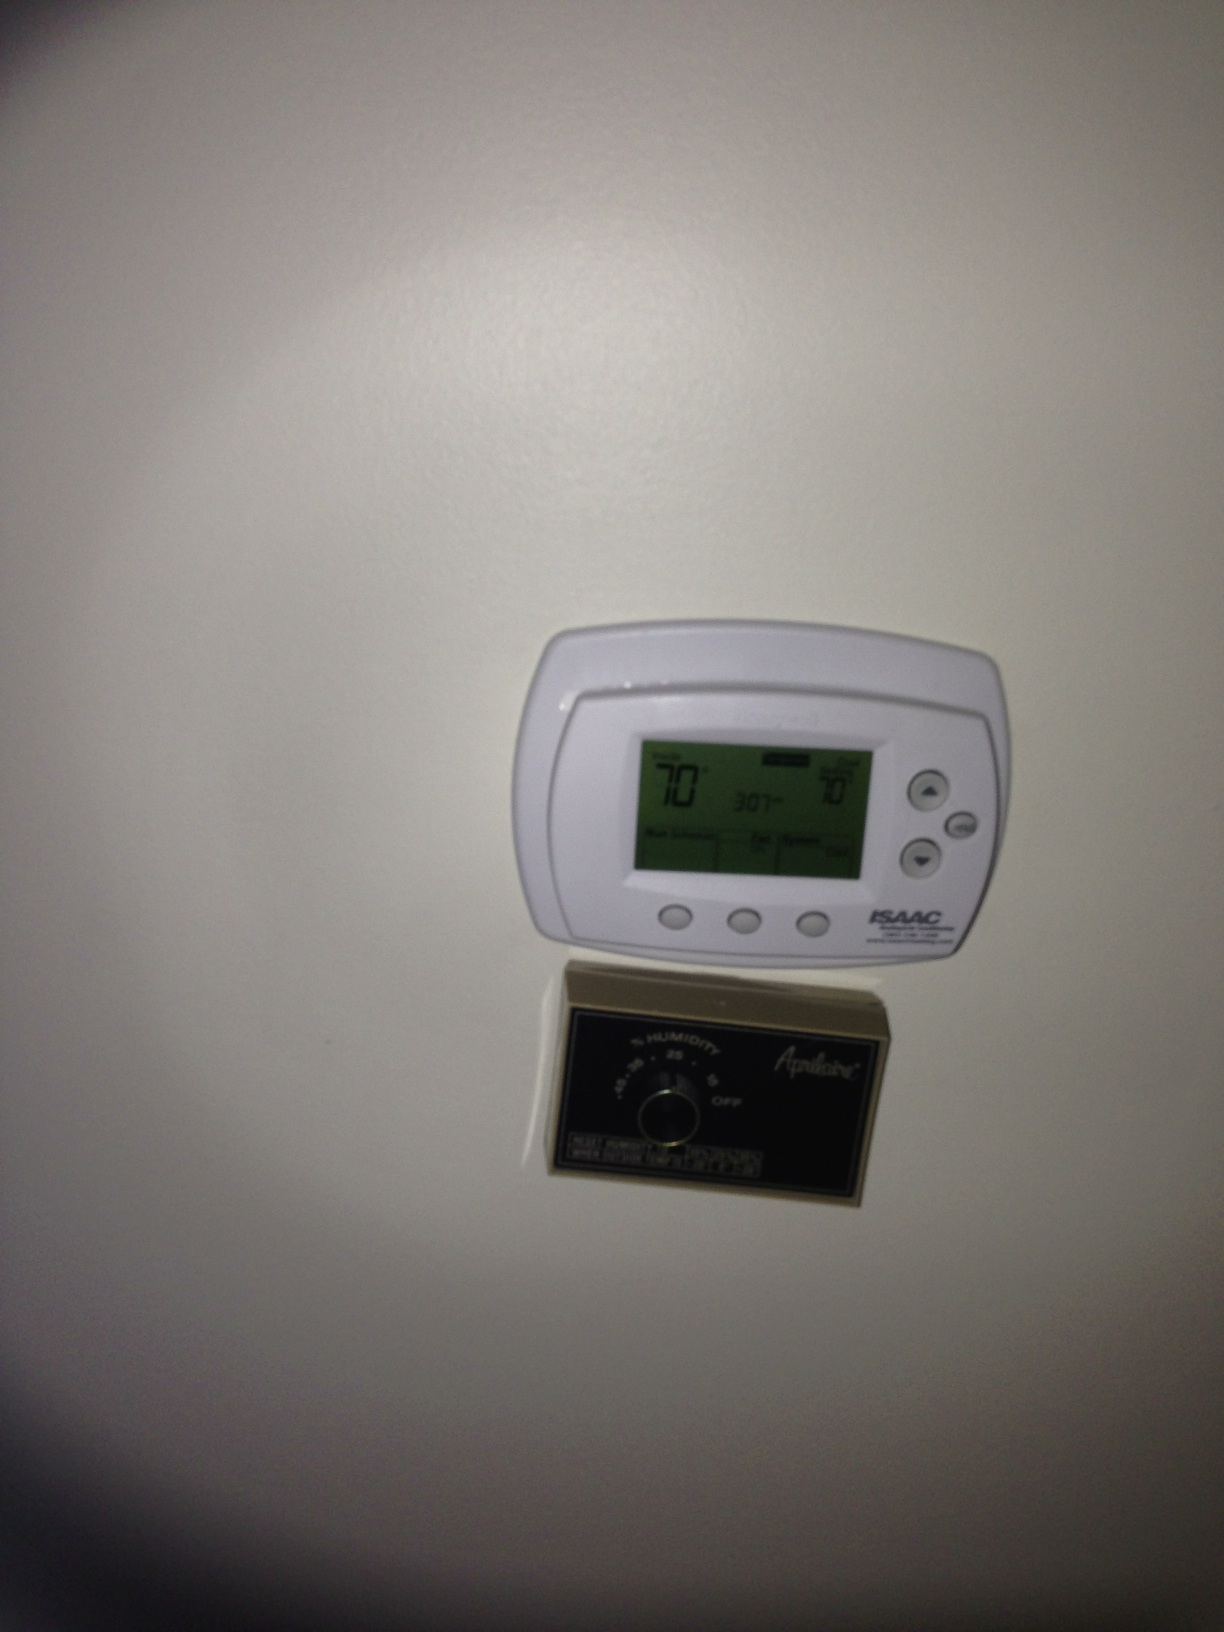What are the bottom buttons from left to right on the thermometer panel? The bottom buttons on the thermometer panel from left to right are 'Fan On/Auto', 'Heat/Cool', and 'Temperature Up/Down' controls. 